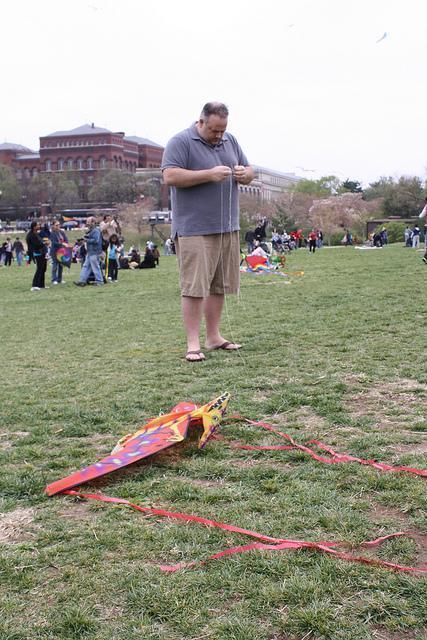What is the red object on the ground capable of?
Make your selection from the four choices given to correctly answer the question.
Options: Driving around, flight, playing music, catching fish. Flight. 